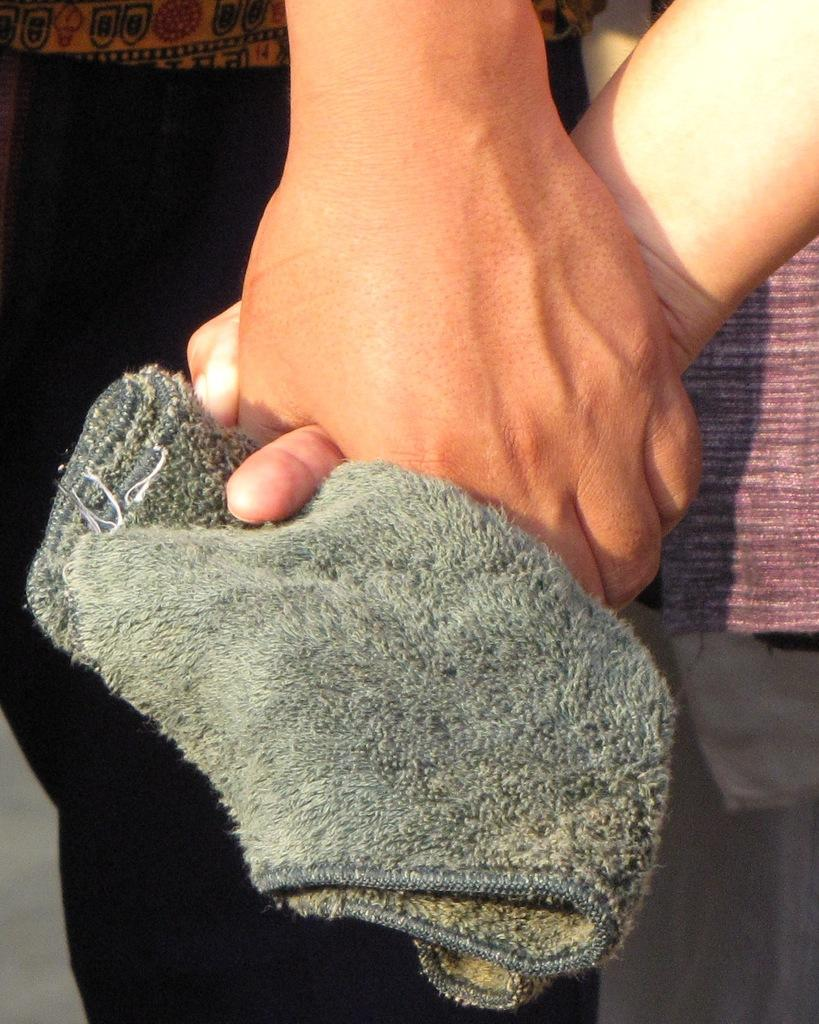How many people are in the image? There are two persons in the image. What are the two persons holding in their hands? The two persons are holding a towel in their hands. What type of glass is being used to catch the robin in the image? There is no glass or robin present in the image; it only features two persons holding a towel. 